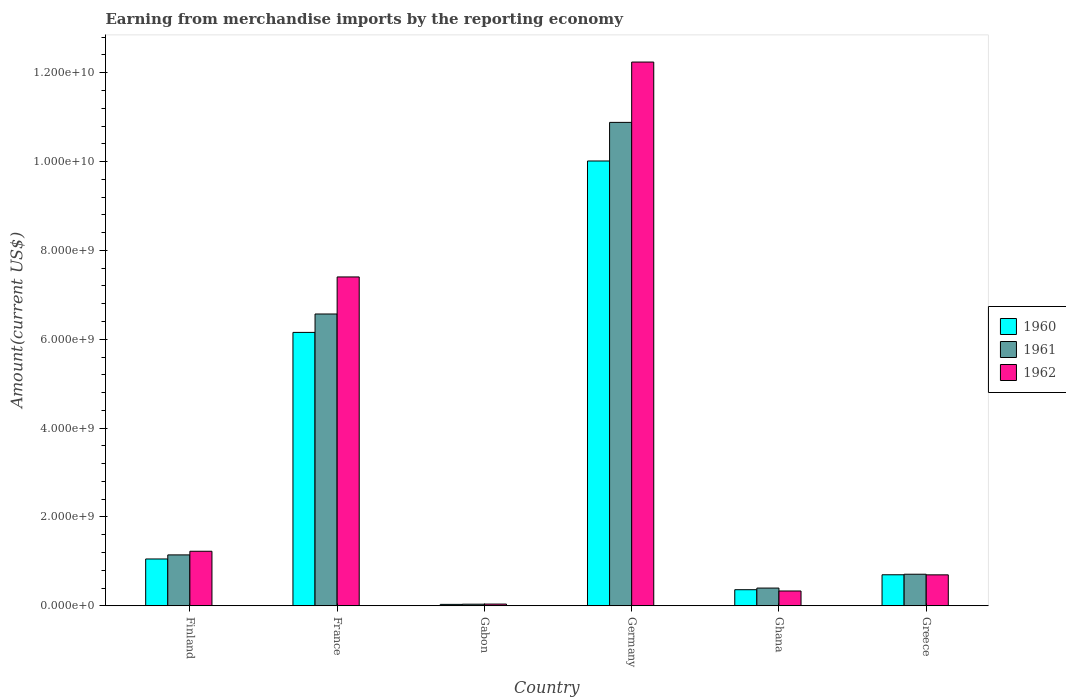In how many cases, is the number of bars for a given country not equal to the number of legend labels?
Give a very brief answer. 0. What is the amount earned from merchandise imports in 1962 in Germany?
Offer a very short reply. 1.22e+1. Across all countries, what is the maximum amount earned from merchandise imports in 1961?
Make the answer very short. 1.09e+1. Across all countries, what is the minimum amount earned from merchandise imports in 1961?
Ensure brevity in your answer.  3.58e+07. In which country was the amount earned from merchandise imports in 1960 minimum?
Provide a short and direct response. Gabon. What is the total amount earned from merchandise imports in 1962 in the graph?
Your response must be concise. 2.19e+1. What is the difference between the amount earned from merchandise imports in 1961 in France and that in Gabon?
Offer a very short reply. 6.53e+09. What is the difference between the amount earned from merchandise imports in 1962 in Germany and the amount earned from merchandise imports in 1961 in Finland?
Provide a short and direct response. 1.11e+1. What is the average amount earned from merchandise imports in 1961 per country?
Provide a succinct answer. 3.29e+09. What is the difference between the amount earned from merchandise imports of/in 1961 and amount earned from merchandise imports of/in 1962 in Germany?
Keep it short and to the point. -1.36e+09. In how many countries, is the amount earned from merchandise imports in 1961 greater than 6000000000 US$?
Give a very brief answer. 2. What is the ratio of the amount earned from merchandise imports in 1962 in Finland to that in Ghana?
Keep it short and to the point. 3.68. Is the difference between the amount earned from merchandise imports in 1961 in Gabon and Greece greater than the difference between the amount earned from merchandise imports in 1962 in Gabon and Greece?
Ensure brevity in your answer.  No. What is the difference between the highest and the second highest amount earned from merchandise imports in 1962?
Offer a very short reply. 4.84e+09. What is the difference between the highest and the lowest amount earned from merchandise imports in 1961?
Ensure brevity in your answer.  1.08e+1. In how many countries, is the amount earned from merchandise imports in 1961 greater than the average amount earned from merchandise imports in 1961 taken over all countries?
Keep it short and to the point. 2. What does the 3rd bar from the left in Germany represents?
Keep it short and to the point. 1962. Is it the case that in every country, the sum of the amount earned from merchandise imports in 1962 and amount earned from merchandise imports in 1960 is greater than the amount earned from merchandise imports in 1961?
Keep it short and to the point. Yes. How many bars are there?
Your answer should be compact. 18. How many countries are there in the graph?
Provide a succinct answer. 6. Are the values on the major ticks of Y-axis written in scientific E-notation?
Provide a succinct answer. Yes. Where does the legend appear in the graph?
Give a very brief answer. Center right. What is the title of the graph?
Ensure brevity in your answer.  Earning from merchandise imports by the reporting economy. Does "1997" appear as one of the legend labels in the graph?
Keep it short and to the point. No. What is the label or title of the X-axis?
Keep it short and to the point. Country. What is the label or title of the Y-axis?
Offer a terse response. Amount(current US$). What is the Amount(current US$) in 1960 in Finland?
Ensure brevity in your answer.  1.05e+09. What is the Amount(current US$) of 1961 in Finland?
Ensure brevity in your answer.  1.15e+09. What is the Amount(current US$) of 1962 in Finland?
Provide a succinct answer. 1.23e+09. What is the Amount(current US$) of 1960 in France?
Offer a very short reply. 6.15e+09. What is the Amount(current US$) in 1961 in France?
Your answer should be compact. 6.57e+09. What is the Amount(current US$) in 1962 in France?
Provide a succinct answer. 7.40e+09. What is the Amount(current US$) in 1960 in Gabon?
Provide a short and direct response. 3.18e+07. What is the Amount(current US$) in 1961 in Gabon?
Offer a very short reply. 3.58e+07. What is the Amount(current US$) in 1962 in Gabon?
Give a very brief answer. 3.88e+07. What is the Amount(current US$) in 1960 in Germany?
Ensure brevity in your answer.  1.00e+1. What is the Amount(current US$) in 1961 in Germany?
Provide a short and direct response. 1.09e+1. What is the Amount(current US$) of 1962 in Germany?
Make the answer very short. 1.22e+1. What is the Amount(current US$) in 1960 in Ghana?
Your response must be concise. 3.62e+08. What is the Amount(current US$) in 1961 in Ghana?
Your answer should be compact. 3.99e+08. What is the Amount(current US$) in 1962 in Ghana?
Keep it short and to the point. 3.33e+08. What is the Amount(current US$) of 1960 in Greece?
Provide a short and direct response. 6.98e+08. What is the Amount(current US$) in 1961 in Greece?
Keep it short and to the point. 7.10e+08. What is the Amount(current US$) in 1962 in Greece?
Keep it short and to the point. 6.96e+08. Across all countries, what is the maximum Amount(current US$) in 1960?
Your response must be concise. 1.00e+1. Across all countries, what is the maximum Amount(current US$) of 1961?
Provide a short and direct response. 1.09e+1. Across all countries, what is the maximum Amount(current US$) in 1962?
Provide a succinct answer. 1.22e+1. Across all countries, what is the minimum Amount(current US$) in 1960?
Offer a terse response. 3.18e+07. Across all countries, what is the minimum Amount(current US$) of 1961?
Offer a terse response. 3.58e+07. Across all countries, what is the minimum Amount(current US$) of 1962?
Provide a succinct answer. 3.88e+07. What is the total Amount(current US$) of 1960 in the graph?
Your answer should be very brief. 1.83e+1. What is the total Amount(current US$) in 1961 in the graph?
Provide a succinct answer. 1.97e+1. What is the total Amount(current US$) in 1962 in the graph?
Ensure brevity in your answer.  2.19e+1. What is the difference between the Amount(current US$) in 1960 in Finland and that in France?
Your response must be concise. -5.10e+09. What is the difference between the Amount(current US$) of 1961 in Finland and that in France?
Provide a succinct answer. -5.42e+09. What is the difference between the Amount(current US$) of 1962 in Finland and that in France?
Your response must be concise. -6.18e+09. What is the difference between the Amount(current US$) in 1960 in Finland and that in Gabon?
Make the answer very short. 1.02e+09. What is the difference between the Amount(current US$) of 1961 in Finland and that in Gabon?
Your response must be concise. 1.11e+09. What is the difference between the Amount(current US$) in 1962 in Finland and that in Gabon?
Your response must be concise. 1.19e+09. What is the difference between the Amount(current US$) in 1960 in Finland and that in Germany?
Ensure brevity in your answer.  -8.96e+09. What is the difference between the Amount(current US$) of 1961 in Finland and that in Germany?
Your response must be concise. -9.74e+09. What is the difference between the Amount(current US$) of 1962 in Finland and that in Germany?
Offer a very short reply. -1.10e+1. What is the difference between the Amount(current US$) of 1960 in Finland and that in Ghana?
Make the answer very short. 6.92e+08. What is the difference between the Amount(current US$) in 1961 in Finland and that in Ghana?
Provide a succinct answer. 7.47e+08. What is the difference between the Amount(current US$) in 1962 in Finland and that in Ghana?
Provide a short and direct response. 8.95e+08. What is the difference between the Amount(current US$) in 1960 in Finland and that in Greece?
Your answer should be very brief. 3.56e+08. What is the difference between the Amount(current US$) in 1961 in Finland and that in Greece?
Offer a very short reply. 4.35e+08. What is the difference between the Amount(current US$) of 1962 in Finland and that in Greece?
Keep it short and to the point. 5.31e+08. What is the difference between the Amount(current US$) in 1960 in France and that in Gabon?
Your answer should be very brief. 6.12e+09. What is the difference between the Amount(current US$) in 1961 in France and that in Gabon?
Give a very brief answer. 6.53e+09. What is the difference between the Amount(current US$) of 1962 in France and that in Gabon?
Keep it short and to the point. 7.36e+09. What is the difference between the Amount(current US$) in 1960 in France and that in Germany?
Ensure brevity in your answer.  -3.86e+09. What is the difference between the Amount(current US$) of 1961 in France and that in Germany?
Offer a very short reply. -4.31e+09. What is the difference between the Amount(current US$) in 1962 in France and that in Germany?
Offer a very short reply. -4.84e+09. What is the difference between the Amount(current US$) in 1960 in France and that in Ghana?
Provide a short and direct response. 5.79e+09. What is the difference between the Amount(current US$) of 1961 in France and that in Ghana?
Ensure brevity in your answer.  6.17e+09. What is the difference between the Amount(current US$) in 1962 in France and that in Ghana?
Your answer should be compact. 7.07e+09. What is the difference between the Amount(current US$) of 1960 in France and that in Greece?
Offer a terse response. 5.46e+09. What is the difference between the Amount(current US$) in 1961 in France and that in Greece?
Offer a very short reply. 5.86e+09. What is the difference between the Amount(current US$) in 1962 in France and that in Greece?
Your answer should be very brief. 6.71e+09. What is the difference between the Amount(current US$) of 1960 in Gabon and that in Germany?
Keep it short and to the point. -9.98e+09. What is the difference between the Amount(current US$) of 1961 in Gabon and that in Germany?
Your response must be concise. -1.08e+1. What is the difference between the Amount(current US$) in 1962 in Gabon and that in Germany?
Keep it short and to the point. -1.22e+1. What is the difference between the Amount(current US$) of 1960 in Gabon and that in Ghana?
Your answer should be very brief. -3.30e+08. What is the difference between the Amount(current US$) of 1961 in Gabon and that in Ghana?
Give a very brief answer. -3.63e+08. What is the difference between the Amount(current US$) of 1962 in Gabon and that in Ghana?
Your answer should be very brief. -2.94e+08. What is the difference between the Amount(current US$) in 1960 in Gabon and that in Greece?
Ensure brevity in your answer.  -6.66e+08. What is the difference between the Amount(current US$) of 1961 in Gabon and that in Greece?
Your answer should be very brief. -6.75e+08. What is the difference between the Amount(current US$) of 1962 in Gabon and that in Greece?
Your answer should be very brief. -6.58e+08. What is the difference between the Amount(current US$) in 1960 in Germany and that in Ghana?
Provide a succinct answer. 9.65e+09. What is the difference between the Amount(current US$) of 1961 in Germany and that in Ghana?
Your response must be concise. 1.05e+1. What is the difference between the Amount(current US$) in 1962 in Germany and that in Ghana?
Provide a succinct answer. 1.19e+1. What is the difference between the Amount(current US$) of 1960 in Germany and that in Greece?
Your answer should be compact. 9.31e+09. What is the difference between the Amount(current US$) in 1961 in Germany and that in Greece?
Your response must be concise. 1.02e+1. What is the difference between the Amount(current US$) of 1962 in Germany and that in Greece?
Your answer should be compact. 1.15e+1. What is the difference between the Amount(current US$) in 1960 in Ghana and that in Greece?
Provide a short and direct response. -3.36e+08. What is the difference between the Amount(current US$) of 1961 in Ghana and that in Greece?
Give a very brief answer. -3.12e+08. What is the difference between the Amount(current US$) of 1962 in Ghana and that in Greece?
Provide a succinct answer. -3.63e+08. What is the difference between the Amount(current US$) of 1960 in Finland and the Amount(current US$) of 1961 in France?
Offer a very short reply. -5.51e+09. What is the difference between the Amount(current US$) of 1960 in Finland and the Amount(current US$) of 1962 in France?
Your answer should be very brief. -6.35e+09. What is the difference between the Amount(current US$) of 1961 in Finland and the Amount(current US$) of 1962 in France?
Make the answer very short. -6.26e+09. What is the difference between the Amount(current US$) of 1960 in Finland and the Amount(current US$) of 1961 in Gabon?
Provide a short and direct response. 1.02e+09. What is the difference between the Amount(current US$) in 1960 in Finland and the Amount(current US$) in 1962 in Gabon?
Ensure brevity in your answer.  1.02e+09. What is the difference between the Amount(current US$) of 1961 in Finland and the Amount(current US$) of 1962 in Gabon?
Give a very brief answer. 1.11e+09. What is the difference between the Amount(current US$) in 1960 in Finland and the Amount(current US$) in 1961 in Germany?
Your response must be concise. -9.83e+09. What is the difference between the Amount(current US$) of 1960 in Finland and the Amount(current US$) of 1962 in Germany?
Provide a short and direct response. -1.12e+1. What is the difference between the Amount(current US$) of 1961 in Finland and the Amount(current US$) of 1962 in Germany?
Offer a very short reply. -1.11e+1. What is the difference between the Amount(current US$) of 1960 in Finland and the Amount(current US$) of 1961 in Ghana?
Provide a succinct answer. 6.55e+08. What is the difference between the Amount(current US$) of 1960 in Finland and the Amount(current US$) of 1962 in Ghana?
Provide a short and direct response. 7.21e+08. What is the difference between the Amount(current US$) of 1961 in Finland and the Amount(current US$) of 1962 in Ghana?
Provide a short and direct response. 8.12e+08. What is the difference between the Amount(current US$) in 1960 in Finland and the Amount(current US$) in 1961 in Greece?
Your answer should be compact. 3.43e+08. What is the difference between the Amount(current US$) of 1960 in Finland and the Amount(current US$) of 1962 in Greece?
Offer a terse response. 3.58e+08. What is the difference between the Amount(current US$) in 1961 in Finland and the Amount(current US$) in 1962 in Greece?
Your answer should be very brief. 4.49e+08. What is the difference between the Amount(current US$) of 1960 in France and the Amount(current US$) of 1961 in Gabon?
Provide a short and direct response. 6.12e+09. What is the difference between the Amount(current US$) of 1960 in France and the Amount(current US$) of 1962 in Gabon?
Provide a short and direct response. 6.12e+09. What is the difference between the Amount(current US$) in 1961 in France and the Amount(current US$) in 1962 in Gabon?
Your answer should be compact. 6.53e+09. What is the difference between the Amount(current US$) in 1960 in France and the Amount(current US$) in 1961 in Germany?
Your answer should be compact. -4.73e+09. What is the difference between the Amount(current US$) in 1960 in France and the Amount(current US$) in 1962 in Germany?
Ensure brevity in your answer.  -6.09e+09. What is the difference between the Amount(current US$) in 1961 in France and the Amount(current US$) in 1962 in Germany?
Your answer should be very brief. -5.67e+09. What is the difference between the Amount(current US$) in 1960 in France and the Amount(current US$) in 1961 in Ghana?
Your answer should be very brief. 5.76e+09. What is the difference between the Amount(current US$) of 1960 in France and the Amount(current US$) of 1962 in Ghana?
Offer a terse response. 5.82e+09. What is the difference between the Amount(current US$) in 1961 in France and the Amount(current US$) in 1962 in Ghana?
Your answer should be compact. 6.24e+09. What is the difference between the Amount(current US$) in 1960 in France and the Amount(current US$) in 1961 in Greece?
Offer a very short reply. 5.44e+09. What is the difference between the Amount(current US$) in 1960 in France and the Amount(current US$) in 1962 in Greece?
Make the answer very short. 5.46e+09. What is the difference between the Amount(current US$) in 1961 in France and the Amount(current US$) in 1962 in Greece?
Provide a succinct answer. 5.87e+09. What is the difference between the Amount(current US$) in 1960 in Gabon and the Amount(current US$) in 1961 in Germany?
Offer a terse response. -1.09e+1. What is the difference between the Amount(current US$) of 1960 in Gabon and the Amount(current US$) of 1962 in Germany?
Make the answer very short. -1.22e+1. What is the difference between the Amount(current US$) of 1961 in Gabon and the Amount(current US$) of 1962 in Germany?
Provide a succinct answer. -1.22e+1. What is the difference between the Amount(current US$) of 1960 in Gabon and the Amount(current US$) of 1961 in Ghana?
Provide a succinct answer. -3.67e+08. What is the difference between the Amount(current US$) of 1960 in Gabon and the Amount(current US$) of 1962 in Ghana?
Keep it short and to the point. -3.01e+08. What is the difference between the Amount(current US$) of 1961 in Gabon and the Amount(current US$) of 1962 in Ghana?
Your answer should be very brief. -2.97e+08. What is the difference between the Amount(current US$) of 1960 in Gabon and the Amount(current US$) of 1961 in Greece?
Provide a short and direct response. -6.79e+08. What is the difference between the Amount(current US$) in 1960 in Gabon and the Amount(current US$) in 1962 in Greece?
Give a very brief answer. -6.65e+08. What is the difference between the Amount(current US$) in 1961 in Gabon and the Amount(current US$) in 1962 in Greece?
Keep it short and to the point. -6.61e+08. What is the difference between the Amount(current US$) in 1960 in Germany and the Amount(current US$) in 1961 in Ghana?
Offer a terse response. 9.61e+09. What is the difference between the Amount(current US$) of 1960 in Germany and the Amount(current US$) of 1962 in Ghana?
Make the answer very short. 9.68e+09. What is the difference between the Amount(current US$) in 1961 in Germany and the Amount(current US$) in 1962 in Ghana?
Provide a succinct answer. 1.05e+1. What is the difference between the Amount(current US$) in 1960 in Germany and the Amount(current US$) in 1961 in Greece?
Your response must be concise. 9.30e+09. What is the difference between the Amount(current US$) of 1960 in Germany and the Amount(current US$) of 1962 in Greece?
Offer a very short reply. 9.32e+09. What is the difference between the Amount(current US$) in 1961 in Germany and the Amount(current US$) in 1962 in Greece?
Offer a very short reply. 1.02e+1. What is the difference between the Amount(current US$) in 1960 in Ghana and the Amount(current US$) in 1961 in Greece?
Make the answer very short. -3.48e+08. What is the difference between the Amount(current US$) in 1960 in Ghana and the Amount(current US$) in 1962 in Greece?
Provide a succinct answer. -3.34e+08. What is the difference between the Amount(current US$) of 1961 in Ghana and the Amount(current US$) of 1962 in Greece?
Your answer should be very brief. -2.98e+08. What is the average Amount(current US$) of 1960 per country?
Your response must be concise. 3.05e+09. What is the average Amount(current US$) in 1961 per country?
Ensure brevity in your answer.  3.29e+09. What is the average Amount(current US$) of 1962 per country?
Keep it short and to the point. 3.66e+09. What is the difference between the Amount(current US$) in 1960 and Amount(current US$) in 1961 in Finland?
Your answer should be compact. -9.18e+07. What is the difference between the Amount(current US$) in 1960 and Amount(current US$) in 1962 in Finland?
Offer a terse response. -1.74e+08. What is the difference between the Amount(current US$) in 1961 and Amount(current US$) in 1962 in Finland?
Offer a very short reply. -8.21e+07. What is the difference between the Amount(current US$) of 1960 and Amount(current US$) of 1961 in France?
Ensure brevity in your answer.  -4.14e+08. What is the difference between the Amount(current US$) of 1960 and Amount(current US$) of 1962 in France?
Keep it short and to the point. -1.25e+09. What is the difference between the Amount(current US$) of 1961 and Amount(current US$) of 1962 in France?
Keep it short and to the point. -8.34e+08. What is the difference between the Amount(current US$) in 1960 and Amount(current US$) in 1961 in Gabon?
Your response must be concise. -4.00e+06. What is the difference between the Amount(current US$) in 1960 and Amount(current US$) in 1962 in Gabon?
Provide a succinct answer. -7.00e+06. What is the difference between the Amount(current US$) in 1961 and Amount(current US$) in 1962 in Gabon?
Offer a terse response. -3.00e+06. What is the difference between the Amount(current US$) of 1960 and Amount(current US$) of 1961 in Germany?
Provide a succinct answer. -8.69e+08. What is the difference between the Amount(current US$) of 1960 and Amount(current US$) of 1962 in Germany?
Your response must be concise. -2.23e+09. What is the difference between the Amount(current US$) in 1961 and Amount(current US$) in 1962 in Germany?
Your answer should be compact. -1.36e+09. What is the difference between the Amount(current US$) in 1960 and Amount(current US$) in 1961 in Ghana?
Your answer should be very brief. -3.67e+07. What is the difference between the Amount(current US$) in 1960 and Amount(current US$) in 1962 in Ghana?
Your answer should be compact. 2.89e+07. What is the difference between the Amount(current US$) in 1961 and Amount(current US$) in 1962 in Ghana?
Make the answer very short. 6.56e+07. What is the difference between the Amount(current US$) of 1960 and Amount(current US$) of 1961 in Greece?
Your answer should be compact. -1.22e+07. What is the difference between the Amount(current US$) of 1960 and Amount(current US$) of 1962 in Greece?
Give a very brief answer. 1.90e+06. What is the difference between the Amount(current US$) of 1961 and Amount(current US$) of 1962 in Greece?
Keep it short and to the point. 1.41e+07. What is the ratio of the Amount(current US$) of 1960 in Finland to that in France?
Your answer should be compact. 0.17. What is the ratio of the Amount(current US$) in 1961 in Finland to that in France?
Keep it short and to the point. 0.17. What is the ratio of the Amount(current US$) in 1962 in Finland to that in France?
Your response must be concise. 0.17. What is the ratio of the Amount(current US$) in 1960 in Finland to that in Gabon?
Give a very brief answer. 33.14. What is the ratio of the Amount(current US$) of 1961 in Finland to that in Gabon?
Your answer should be compact. 32. What is the ratio of the Amount(current US$) in 1962 in Finland to that in Gabon?
Offer a terse response. 31.64. What is the ratio of the Amount(current US$) of 1960 in Finland to that in Germany?
Your response must be concise. 0.11. What is the ratio of the Amount(current US$) of 1961 in Finland to that in Germany?
Your response must be concise. 0.11. What is the ratio of the Amount(current US$) in 1962 in Finland to that in Germany?
Keep it short and to the point. 0.1. What is the ratio of the Amount(current US$) in 1960 in Finland to that in Ghana?
Give a very brief answer. 2.91. What is the ratio of the Amount(current US$) of 1961 in Finland to that in Ghana?
Your response must be concise. 2.87. What is the ratio of the Amount(current US$) of 1962 in Finland to that in Ghana?
Your answer should be very brief. 3.68. What is the ratio of the Amount(current US$) of 1960 in Finland to that in Greece?
Provide a short and direct response. 1.51. What is the ratio of the Amount(current US$) of 1961 in Finland to that in Greece?
Provide a short and direct response. 1.61. What is the ratio of the Amount(current US$) of 1962 in Finland to that in Greece?
Make the answer very short. 1.76. What is the ratio of the Amount(current US$) in 1960 in France to that in Gabon?
Ensure brevity in your answer.  193.53. What is the ratio of the Amount(current US$) of 1961 in France to that in Gabon?
Your answer should be compact. 183.48. What is the ratio of the Amount(current US$) in 1962 in France to that in Gabon?
Your response must be concise. 190.8. What is the ratio of the Amount(current US$) of 1960 in France to that in Germany?
Offer a terse response. 0.61. What is the ratio of the Amount(current US$) of 1961 in France to that in Germany?
Offer a terse response. 0.6. What is the ratio of the Amount(current US$) of 1962 in France to that in Germany?
Your answer should be very brief. 0.6. What is the ratio of the Amount(current US$) in 1960 in France to that in Ghana?
Make the answer very short. 17. What is the ratio of the Amount(current US$) in 1961 in France to that in Ghana?
Your response must be concise. 16.47. What is the ratio of the Amount(current US$) in 1962 in France to that in Ghana?
Your response must be concise. 22.22. What is the ratio of the Amount(current US$) of 1960 in France to that in Greece?
Keep it short and to the point. 8.81. What is the ratio of the Amount(current US$) in 1961 in France to that in Greece?
Ensure brevity in your answer.  9.25. What is the ratio of the Amount(current US$) in 1962 in France to that in Greece?
Ensure brevity in your answer.  10.63. What is the ratio of the Amount(current US$) of 1960 in Gabon to that in Germany?
Make the answer very short. 0. What is the ratio of the Amount(current US$) in 1961 in Gabon to that in Germany?
Make the answer very short. 0. What is the ratio of the Amount(current US$) of 1962 in Gabon to that in Germany?
Your response must be concise. 0. What is the ratio of the Amount(current US$) of 1960 in Gabon to that in Ghana?
Ensure brevity in your answer.  0.09. What is the ratio of the Amount(current US$) in 1961 in Gabon to that in Ghana?
Your answer should be compact. 0.09. What is the ratio of the Amount(current US$) in 1962 in Gabon to that in Ghana?
Provide a succinct answer. 0.12. What is the ratio of the Amount(current US$) of 1960 in Gabon to that in Greece?
Your answer should be very brief. 0.05. What is the ratio of the Amount(current US$) in 1961 in Gabon to that in Greece?
Make the answer very short. 0.05. What is the ratio of the Amount(current US$) of 1962 in Gabon to that in Greece?
Give a very brief answer. 0.06. What is the ratio of the Amount(current US$) in 1960 in Germany to that in Ghana?
Ensure brevity in your answer.  27.65. What is the ratio of the Amount(current US$) of 1961 in Germany to that in Ghana?
Keep it short and to the point. 27.29. What is the ratio of the Amount(current US$) in 1962 in Germany to that in Ghana?
Ensure brevity in your answer.  36.73. What is the ratio of the Amount(current US$) of 1960 in Germany to that in Greece?
Make the answer very short. 14.34. What is the ratio of the Amount(current US$) in 1961 in Germany to that in Greece?
Your answer should be very brief. 15.32. What is the ratio of the Amount(current US$) of 1962 in Germany to that in Greece?
Your answer should be very brief. 17.58. What is the ratio of the Amount(current US$) of 1960 in Ghana to that in Greece?
Provide a short and direct response. 0.52. What is the ratio of the Amount(current US$) in 1961 in Ghana to that in Greece?
Provide a succinct answer. 0.56. What is the ratio of the Amount(current US$) in 1962 in Ghana to that in Greece?
Your answer should be very brief. 0.48. What is the difference between the highest and the second highest Amount(current US$) of 1960?
Your answer should be very brief. 3.86e+09. What is the difference between the highest and the second highest Amount(current US$) of 1961?
Your response must be concise. 4.31e+09. What is the difference between the highest and the second highest Amount(current US$) in 1962?
Ensure brevity in your answer.  4.84e+09. What is the difference between the highest and the lowest Amount(current US$) of 1960?
Your response must be concise. 9.98e+09. What is the difference between the highest and the lowest Amount(current US$) in 1961?
Your response must be concise. 1.08e+1. What is the difference between the highest and the lowest Amount(current US$) of 1962?
Ensure brevity in your answer.  1.22e+1. 